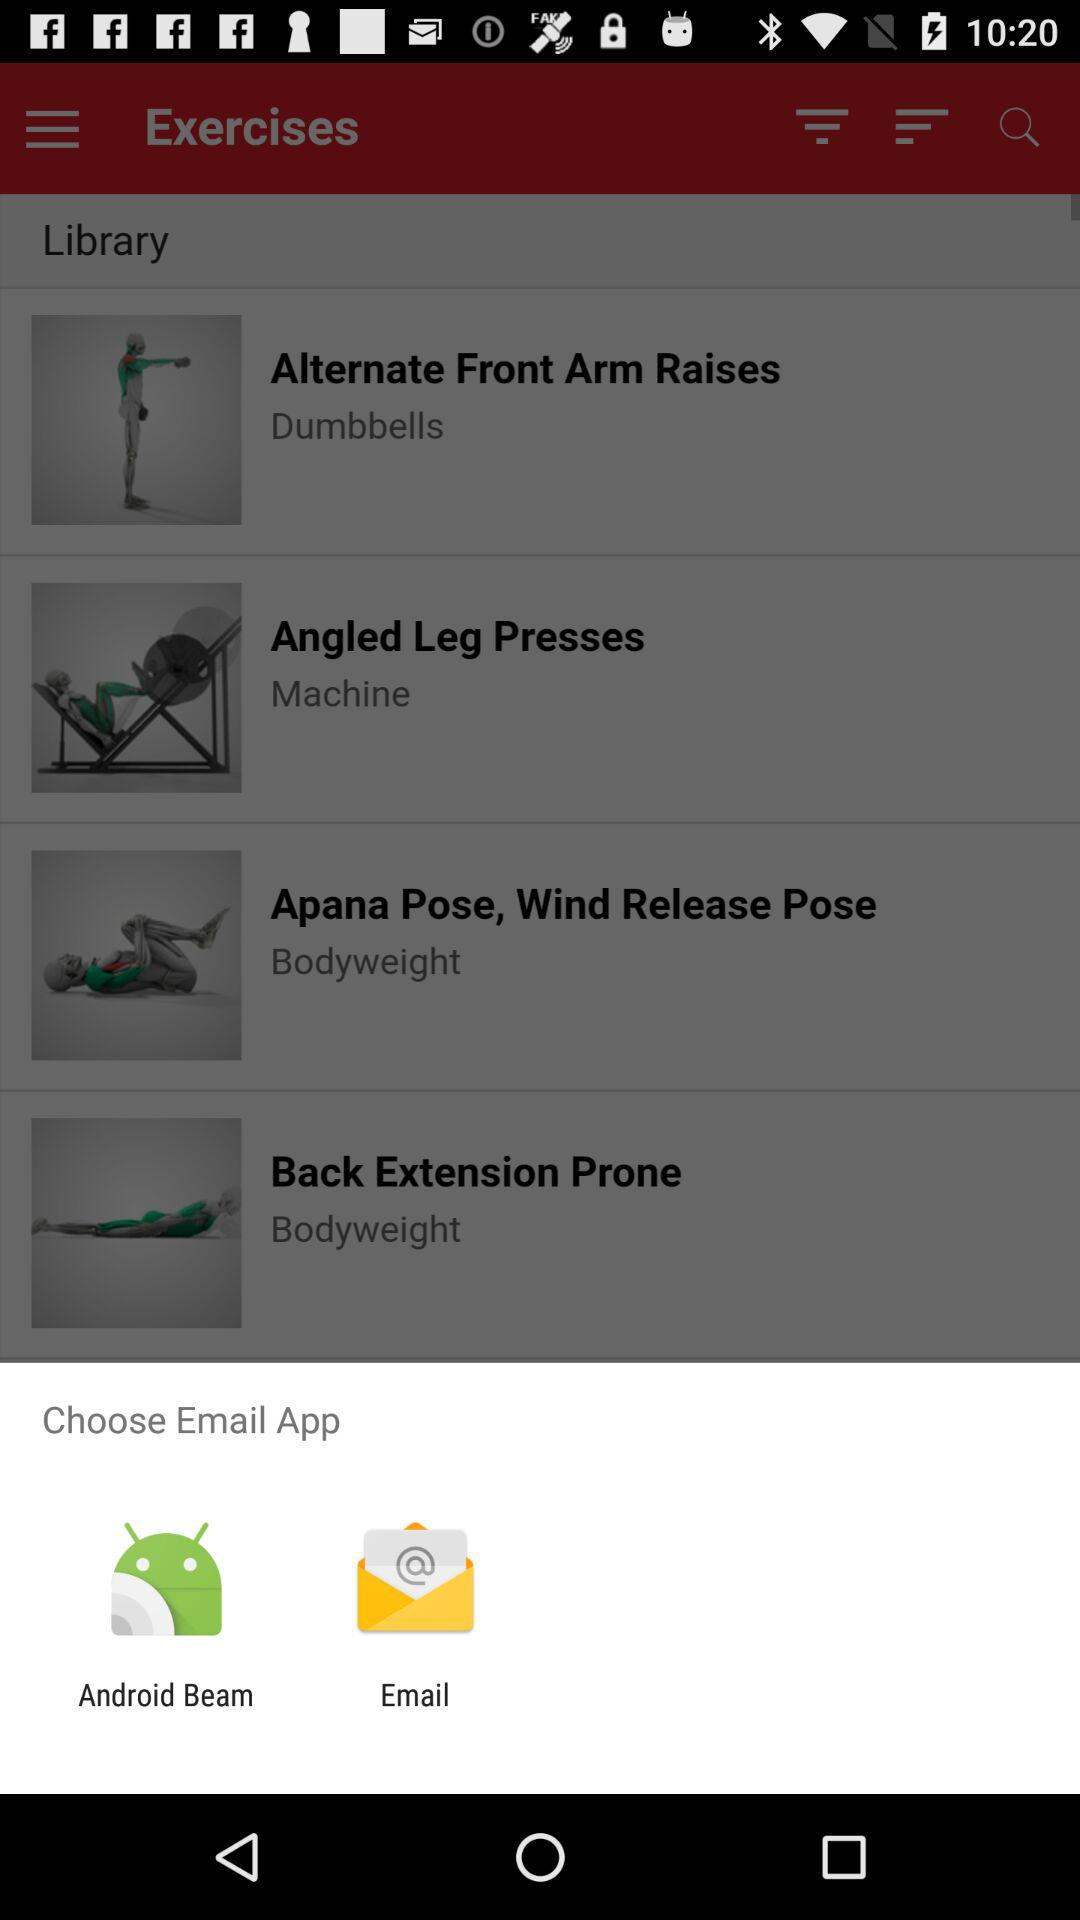Which exercise can be done using a machine? The exercise that can be done using a machine is "Angled Leg Presses". 